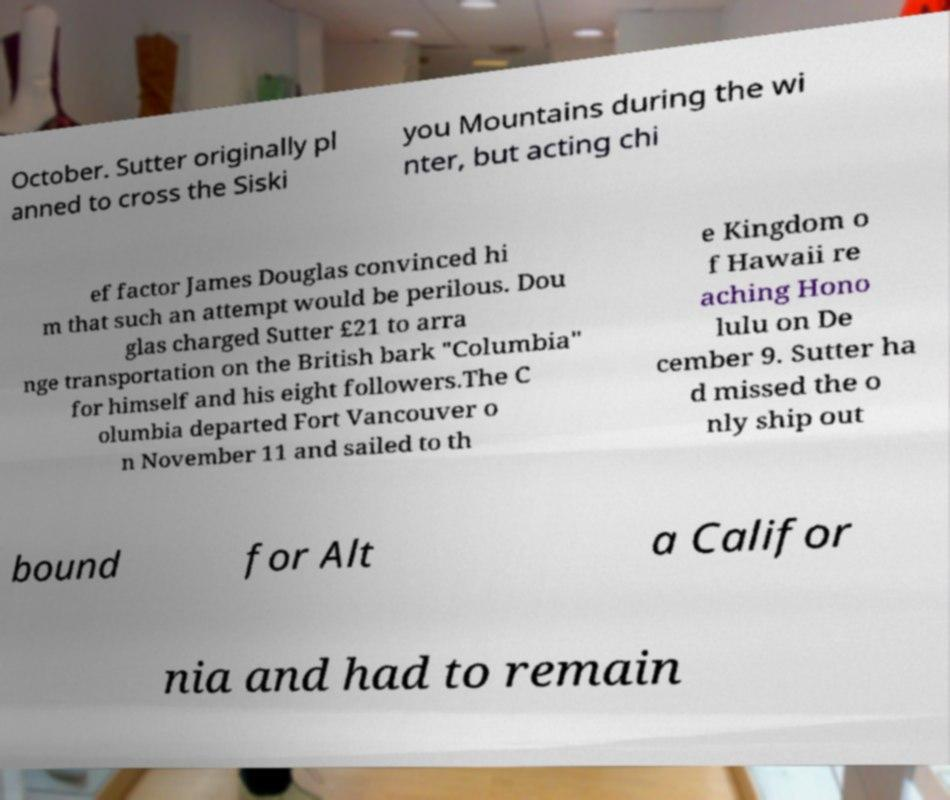Could you assist in decoding the text presented in this image and type it out clearly? October. Sutter originally pl anned to cross the Siski you Mountains during the wi nter, but acting chi ef factor James Douglas convinced hi m that such an attempt would be perilous. Dou glas charged Sutter £21 to arra nge transportation on the British bark "Columbia" for himself and his eight followers.The C olumbia departed Fort Vancouver o n November 11 and sailed to th e Kingdom o f Hawaii re aching Hono lulu on De cember 9. Sutter ha d missed the o nly ship out bound for Alt a Califor nia and had to remain 